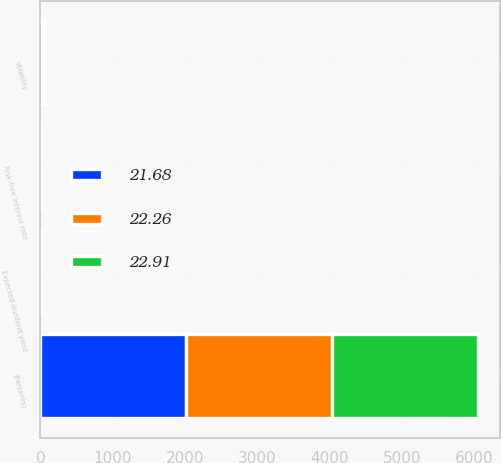Convert chart. <chart><loc_0><loc_0><loc_500><loc_500><stacked_bar_chart><ecel><fcel>(Percents)<fcel>Expected dividend yield<fcel>Risk-free interest rate<fcel>Volatility<nl><fcel>22.26<fcel>2018<fcel>2.5<fcel>2.31<fcel>22.26<nl><fcel>22.91<fcel>2017<fcel>2.5<fcel>1.38<fcel>22.91<nl><fcel>21.68<fcel>2016<fcel>2<fcel>0.92<fcel>21.68<nl></chart> 